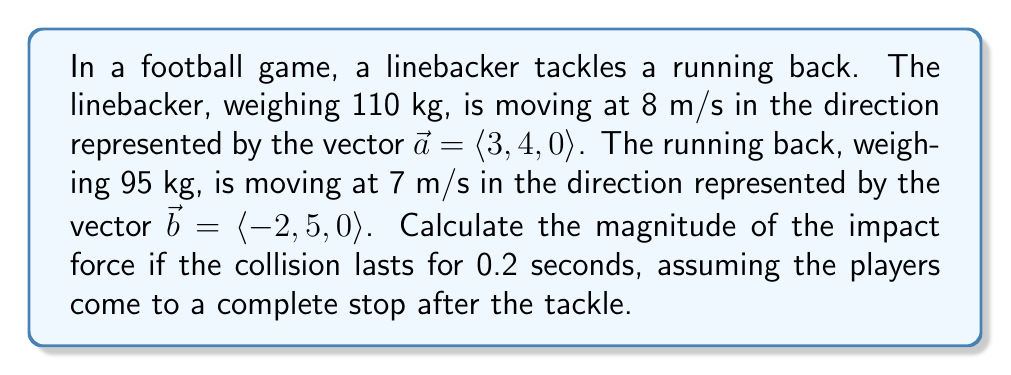Solve this math problem. To solve this problem, we'll use the concept of vector dot products and the impulse-momentum theorem. Let's break it down step by step:

1) First, we need to find the relative velocity vector of the collision. This is the difference between the linebacker's velocity vector and the running back's velocity vector:

   $\vec{v}_{rel} = 8\frac{\vec{a}}{|\vec{a}|} - 7\frac{\vec{b}}{|\vec{b}|}$

2) Calculate the magnitudes of $\vec{a}$ and $\vec{b}$:
   
   $|\vec{a}| = \sqrt{3^2 + 4^2 + 0^2} = 5$
   $|\vec{b}| = \sqrt{(-2)^2 + 5^2 + 0^2} = \sqrt{29}$

3) Now we can calculate $\vec{v}_{rel}$:

   $\vec{v}_{rel} = 8\frac{\langle 3, 4, 0 \rangle}{5} - 7\frac{\langle -2, 5, 0 \rangle}{\sqrt{29}}$
   
   $= \langle 4.8, 6.4, 0 \rangle - \langle -2.6, 6.5, 0 \rangle$
   
   $= \langle 7.4, -0.1, 0 \rangle$

4) The magnitude of the relative velocity is:

   $|\vec{v}_{rel}| = \sqrt{7.4^2 + (-0.1)^2 + 0^2} \approx 7.4$ m/s

5) Now, we use the impulse-momentum theorem. The change in momentum is equal to the impulse:

   $F \cdot \Delta t = m \cdot \Delta v$

   Where $m$ is the reduced mass of the system:
   
   $m = \frac{m_1 m_2}{m_1 + m_2} = \frac{110 \cdot 95}{110 + 95} \approx 51.2$ kg

6) Rearranging the impulse-momentum equation to solve for force:

   $F = \frac{m \cdot \Delta v}{\Delta t} = \frac{51.2 \cdot 7.4}{0.2} \approx 1894.4$ N

Therefore, the magnitude of the impact force is approximately 1894.4 N.
Answer: The magnitude of the impact force is approximately 1894.4 N. 